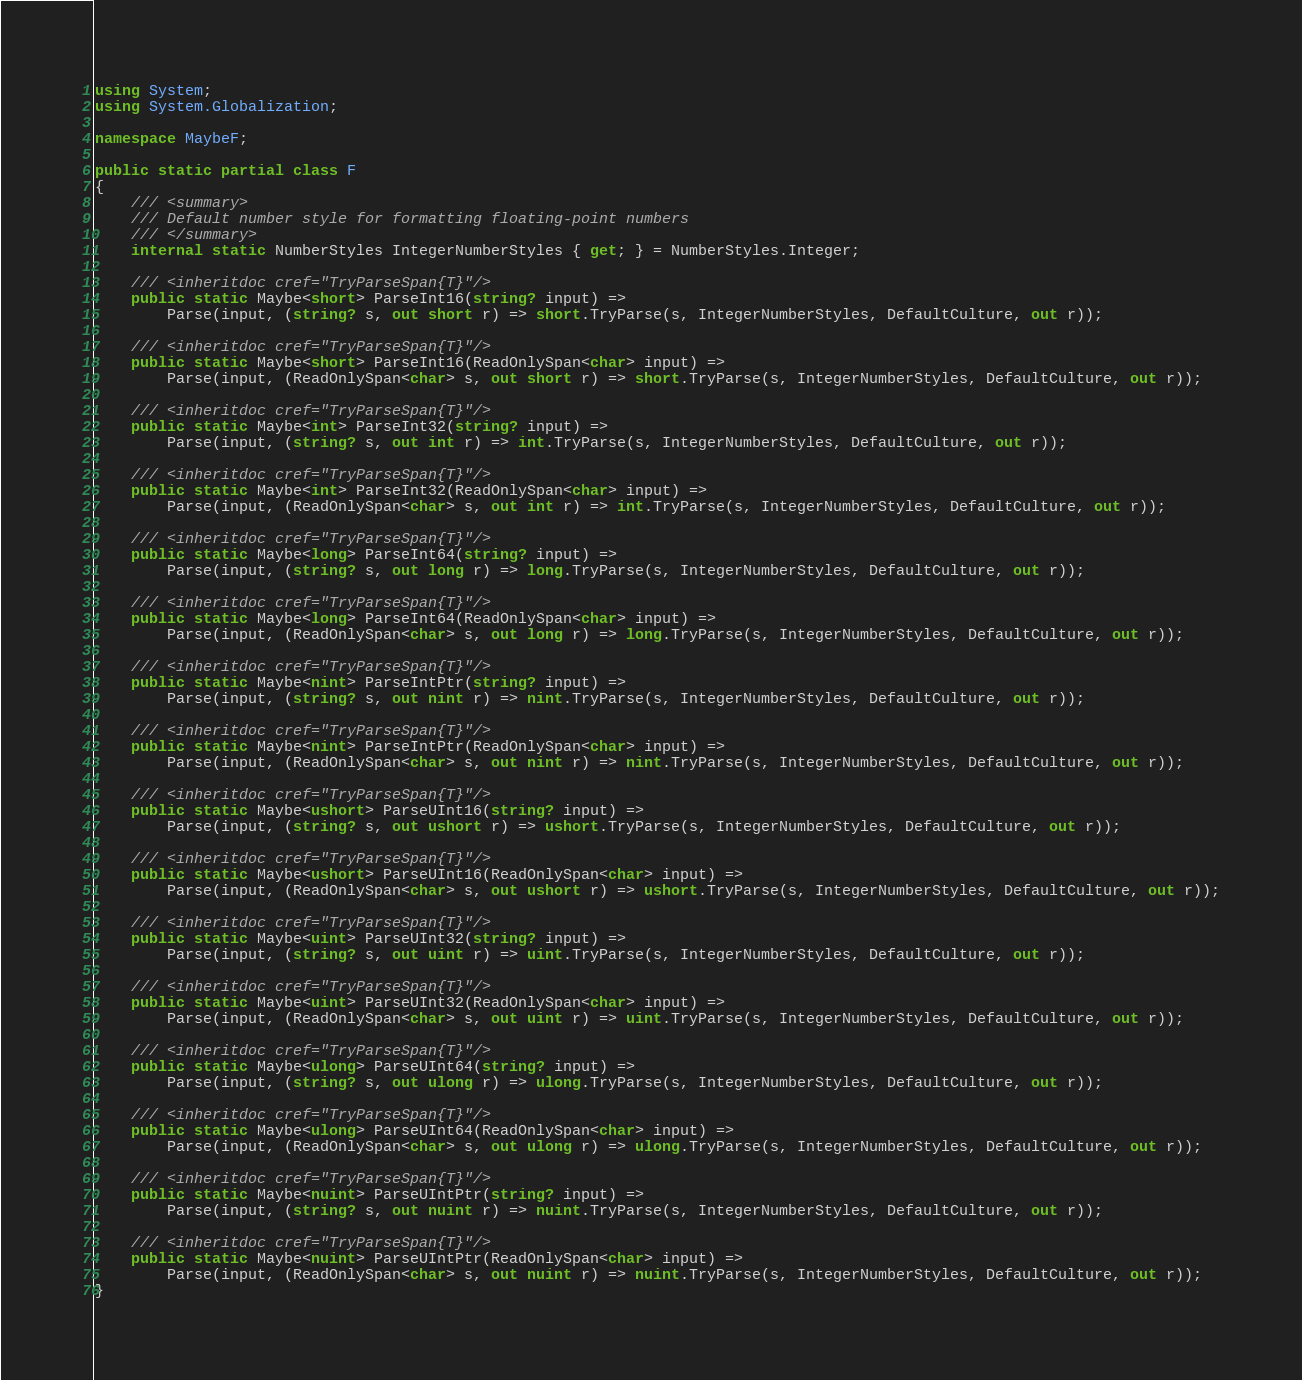Convert code to text. <code><loc_0><loc_0><loc_500><loc_500><_C#_>using System;
using System.Globalization;

namespace MaybeF;

public static partial class F
{
	/// <summary>
	/// Default number style for formatting floating-point numbers
	/// </summary>
	internal static NumberStyles IntegerNumberStyles { get; } = NumberStyles.Integer;

	/// <inheritdoc cref="TryParseSpan{T}"/>
	public static Maybe<short> ParseInt16(string? input) =>
		Parse(input, (string? s, out short r) => short.TryParse(s, IntegerNumberStyles, DefaultCulture, out r));

	/// <inheritdoc cref="TryParseSpan{T}"/>
	public static Maybe<short> ParseInt16(ReadOnlySpan<char> input) =>
		Parse(input, (ReadOnlySpan<char> s, out short r) => short.TryParse(s, IntegerNumberStyles, DefaultCulture, out r));

	/// <inheritdoc cref="TryParseSpan{T}"/>
	public static Maybe<int> ParseInt32(string? input) =>
		Parse(input, (string? s, out int r) => int.TryParse(s, IntegerNumberStyles, DefaultCulture, out r));

	/// <inheritdoc cref="TryParseSpan{T}"/>
	public static Maybe<int> ParseInt32(ReadOnlySpan<char> input) =>
		Parse(input, (ReadOnlySpan<char> s, out int r) => int.TryParse(s, IntegerNumberStyles, DefaultCulture, out r));

	/// <inheritdoc cref="TryParseSpan{T}"/>
	public static Maybe<long> ParseInt64(string? input) =>
		Parse(input, (string? s, out long r) => long.TryParse(s, IntegerNumberStyles, DefaultCulture, out r));

	/// <inheritdoc cref="TryParseSpan{T}"/>
	public static Maybe<long> ParseInt64(ReadOnlySpan<char> input) =>
		Parse(input, (ReadOnlySpan<char> s, out long r) => long.TryParse(s, IntegerNumberStyles, DefaultCulture, out r));

	/// <inheritdoc cref="TryParseSpan{T}"/>
	public static Maybe<nint> ParseIntPtr(string? input) =>
		Parse(input, (string? s, out nint r) => nint.TryParse(s, IntegerNumberStyles, DefaultCulture, out r));

	/// <inheritdoc cref="TryParseSpan{T}"/>
	public static Maybe<nint> ParseIntPtr(ReadOnlySpan<char> input) =>
		Parse(input, (ReadOnlySpan<char> s, out nint r) => nint.TryParse(s, IntegerNumberStyles, DefaultCulture, out r));

	/// <inheritdoc cref="TryParseSpan{T}"/>
	public static Maybe<ushort> ParseUInt16(string? input) =>
		Parse(input, (string? s, out ushort r) => ushort.TryParse(s, IntegerNumberStyles, DefaultCulture, out r));

	/// <inheritdoc cref="TryParseSpan{T}"/>
	public static Maybe<ushort> ParseUInt16(ReadOnlySpan<char> input) =>
		Parse(input, (ReadOnlySpan<char> s, out ushort r) => ushort.TryParse(s, IntegerNumberStyles, DefaultCulture, out r));

	/// <inheritdoc cref="TryParseSpan{T}"/>
	public static Maybe<uint> ParseUInt32(string? input) =>
		Parse(input, (string? s, out uint r) => uint.TryParse(s, IntegerNumberStyles, DefaultCulture, out r));

	/// <inheritdoc cref="TryParseSpan{T}"/>
	public static Maybe<uint> ParseUInt32(ReadOnlySpan<char> input) =>
		Parse(input, (ReadOnlySpan<char> s, out uint r) => uint.TryParse(s, IntegerNumberStyles, DefaultCulture, out r));

	/// <inheritdoc cref="TryParseSpan{T}"/>
	public static Maybe<ulong> ParseUInt64(string? input) =>
		Parse(input, (string? s, out ulong r) => ulong.TryParse(s, IntegerNumberStyles, DefaultCulture, out r));

	/// <inheritdoc cref="TryParseSpan{T}"/>
	public static Maybe<ulong> ParseUInt64(ReadOnlySpan<char> input) =>
		Parse(input, (ReadOnlySpan<char> s, out ulong r) => ulong.TryParse(s, IntegerNumberStyles, DefaultCulture, out r));

	/// <inheritdoc cref="TryParseSpan{T}"/>
	public static Maybe<nuint> ParseUIntPtr(string? input) =>
		Parse(input, (string? s, out nuint r) => nuint.TryParse(s, IntegerNumberStyles, DefaultCulture, out r));

	/// <inheritdoc cref="TryParseSpan{T}"/>
	public static Maybe<nuint> ParseUIntPtr(ReadOnlySpan<char> input) =>
		Parse(input, (ReadOnlySpan<char> s, out nuint r) => nuint.TryParse(s, IntegerNumberStyles, DefaultCulture, out r));
}
</code> 